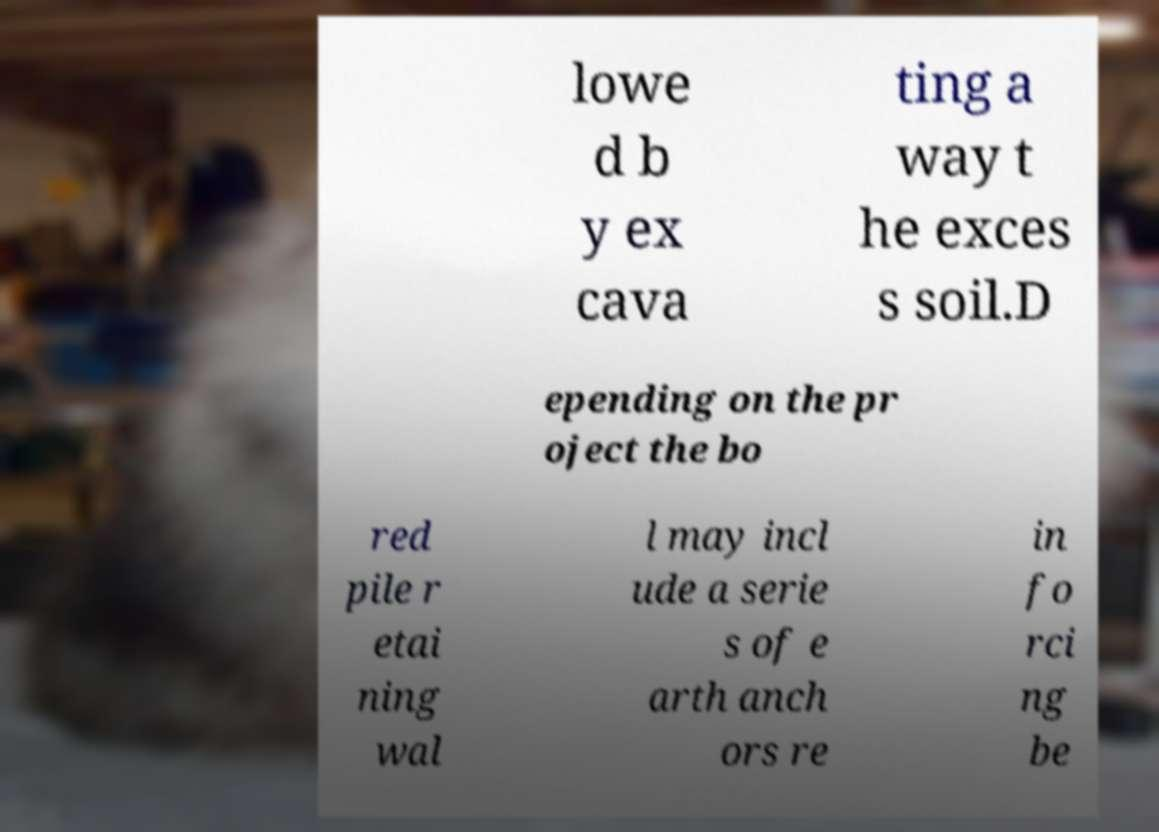I need the written content from this picture converted into text. Can you do that? lowe d b y ex cava ting a way t he exces s soil.D epending on the pr oject the bo red pile r etai ning wal l may incl ude a serie s of e arth anch ors re in fo rci ng be 